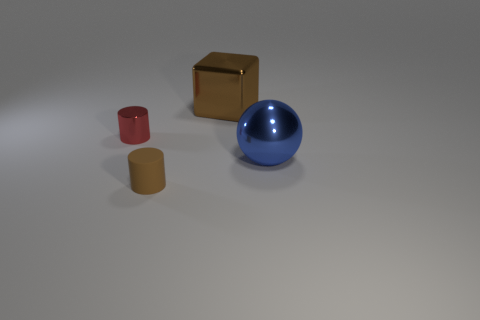Subtract all red cylinders. How many cylinders are left? 1 Subtract all blocks. How many objects are left? 3 Subtract 1 cylinders. How many cylinders are left? 1 Add 2 tiny blue objects. How many objects exist? 6 Subtract 0 green cylinders. How many objects are left? 4 Subtract all gray cylinders. Subtract all gray balls. How many cylinders are left? 2 Subtract all red cylinders. How many gray blocks are left? 0 Subtract all small rubber cylinders. Subtract all big green cubes. How many objects are left? 3 Add 1 brown cylinders. How many brown cylinders are left? 2 Add 4 big cyan matte spheres. How many big cyan matte spheres exist? 4 